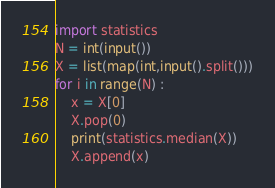<code> <loc_0><loc_0><loc_500><loc_500><_Python_>import statistics
N = int(input())
X = list(map(int,input().split()))
for i in range(N) :
    x = X[0]
    X.pop(0)
    print(statistics.median(X))
    X.append(x)

</code> 